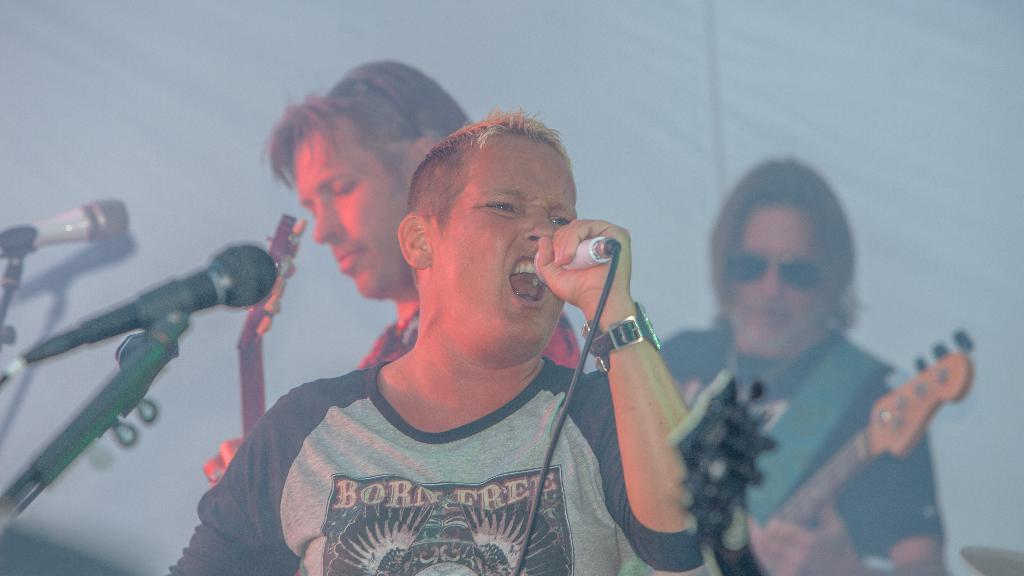Please provide a concise description of this image. In this picture we can see a man standing and holding a mike in his hand and singing. On the background we can see two men standing and playing guitars. These are mike's. 